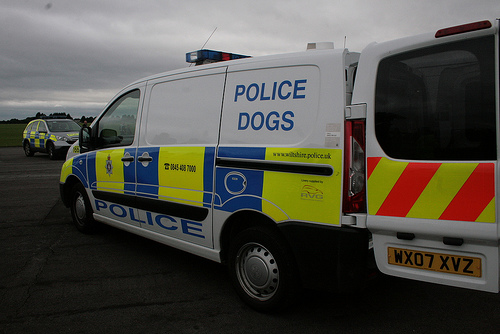<image>
Can you confirm if the van is behind the van? Yes. From this viewpoint, the van is positioned behind the van, with the van partially or fully occluding the van. 